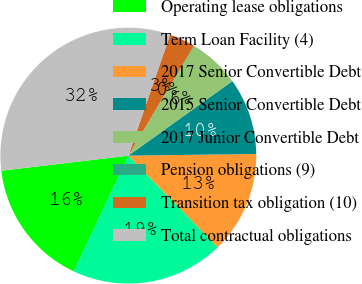Convert chart to OTSL. <chart><loc_0><loc_0><loc_500><loc_500><pie_chart><fcel>Operating lease obligations<fcel>Term Loan Facility (4)<fcel>2017 Senior Convertible Debt<fcel>2015 Senior Convertible Debt<fcel>2017 Junior Convertible Debt<fcel>Pension obligations (9)<fcel>Transition tax obligation (10)<fcel>Total contractual obligations<nl><fcel>16.11%<fcel>19.32%<fcel>12.9%<fcel>9.69%<fcel>6.48%<fcel>0.06%<fcel>3.27%<fcel>32.16%<nl></chart> 